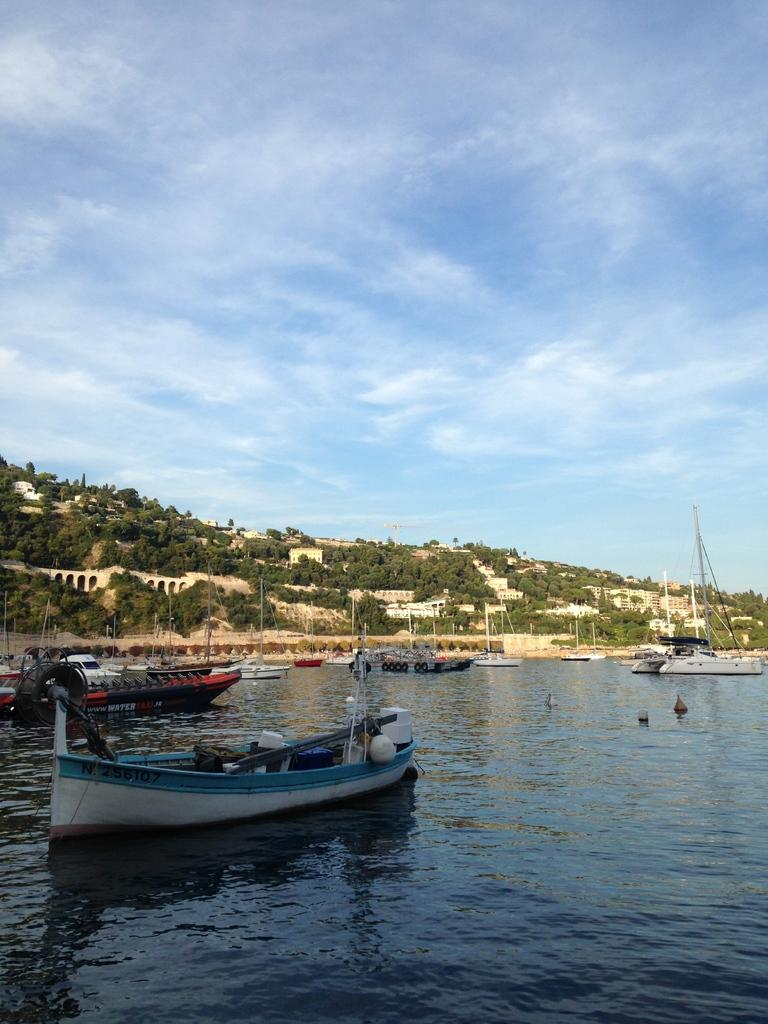What is the main subject of the image? The main subject of the image is boats. Where are the boats located? The boats are on the water. What can be seen in the background of the image? There are trees and the sky visible in the background of the image. What is the color of the trees in the image? The trees are green. What is the color of the sky in the image? The sky is blue and white. Can you see any snakes or ducks in the image? There are no snakes or ducks present in the image. Is there a window visible in the image? There is no window visible in the image; it features boats on the water with a background of trees and the sky. 